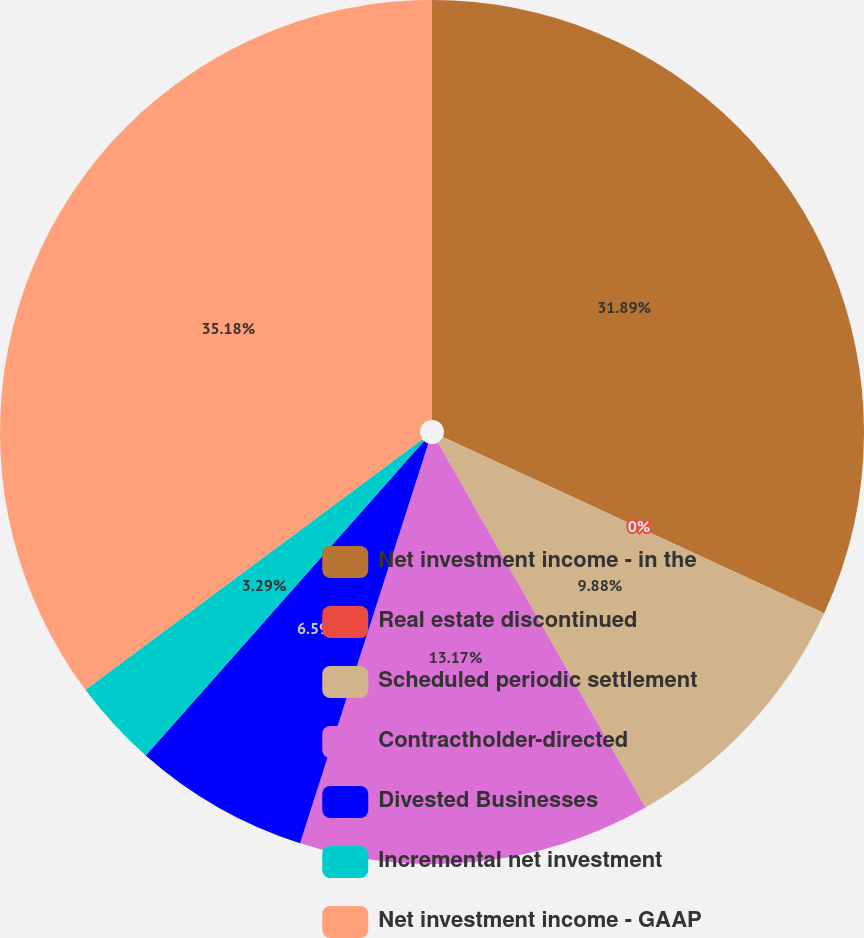Convert chart to OTSL. <chart><loc_0><loc_0><loc_500><loc_500><pie_chart><fcel>Net investment income - in the<fcel>Real estate discontinued<fcel>Scheduled periodic settlement<fcel>Contractholder-directed<fcel>Divested Businesses<fcel>Incremental net investment<fcel>Net investment income - GAAP<nl><fcel>31.89%<fcel>0.0%<fcel>9.88%<fcel>13.17%<fcel>6.59%<fcel>3.29%<fcel>35.18%<nl></chart> 